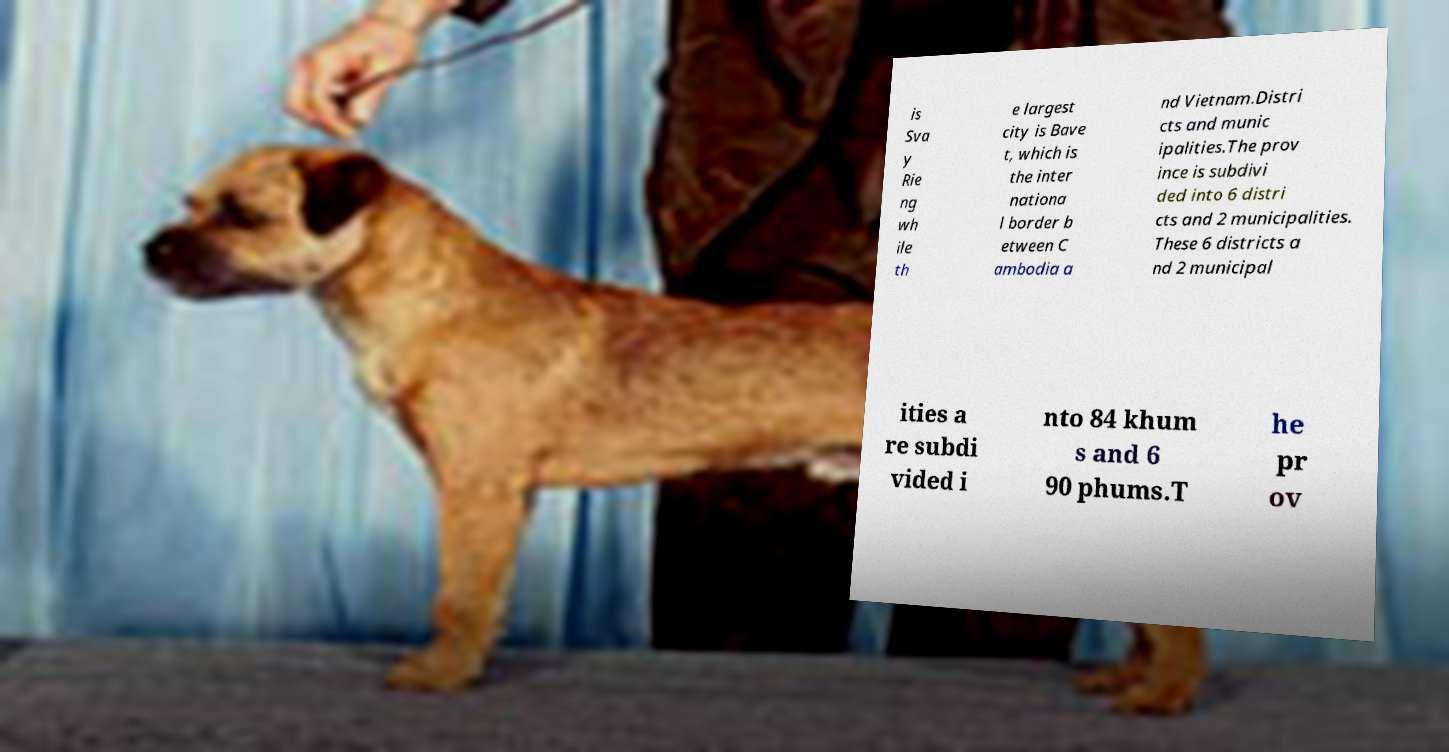Could you assist in decoding the text presented in this image and type it out clearly? is Sva y Rie ng wh ile th e largest city is Bave t, which is the inter nationa l border b etween C ambodia a nd Vietnam.Distri cts and munic ipalities.The prov ince is subdivi ded into 6 distri cts and 2 municipalities. These 6 districts a nd 2 municipal ities a re subdi vided i nto 84 khum s and 6 90 phums.T he pr ov 